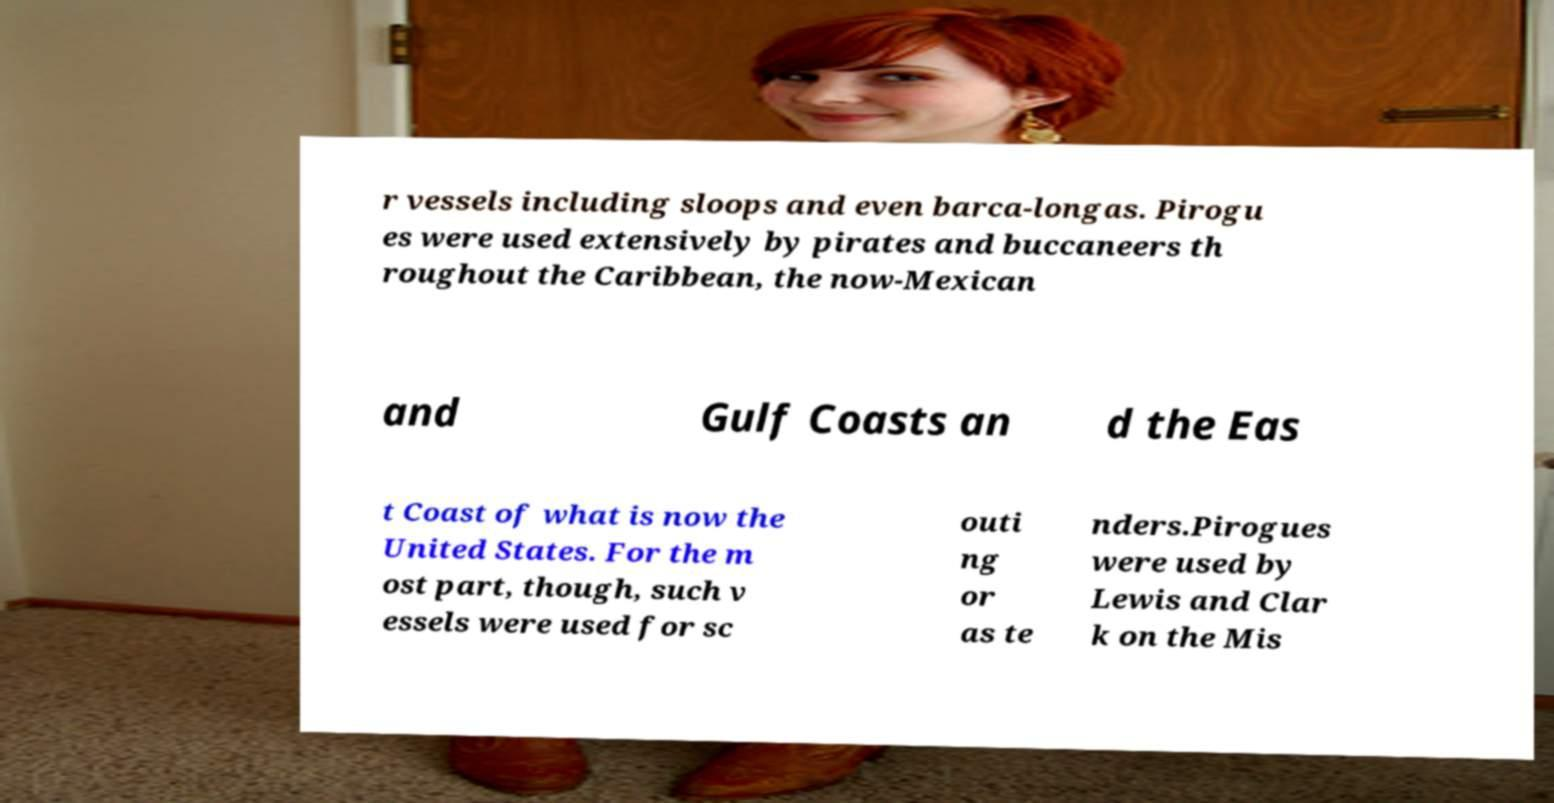Can you accurately transcribe the text from the provided image for me? r vessels including sloops and even barca-longas. Pirogu es were used extensively by pirates and buccaneers th roughout the Caribbean, the now-Mexican and Gulf Coasts an d the Eas t Coast of what is now the United States. For the m ost part, though, such v essels were used for sc outi ng or as te nders.Pirogues were used by Lewis and Clar k on the Mis 